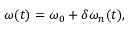<formula> <loc_0><loc_0><loc_500><loc_500>\omega ( t ) = \omega _ { 0 } + \delta \omega _ { n } ( t ) ,</formula> 